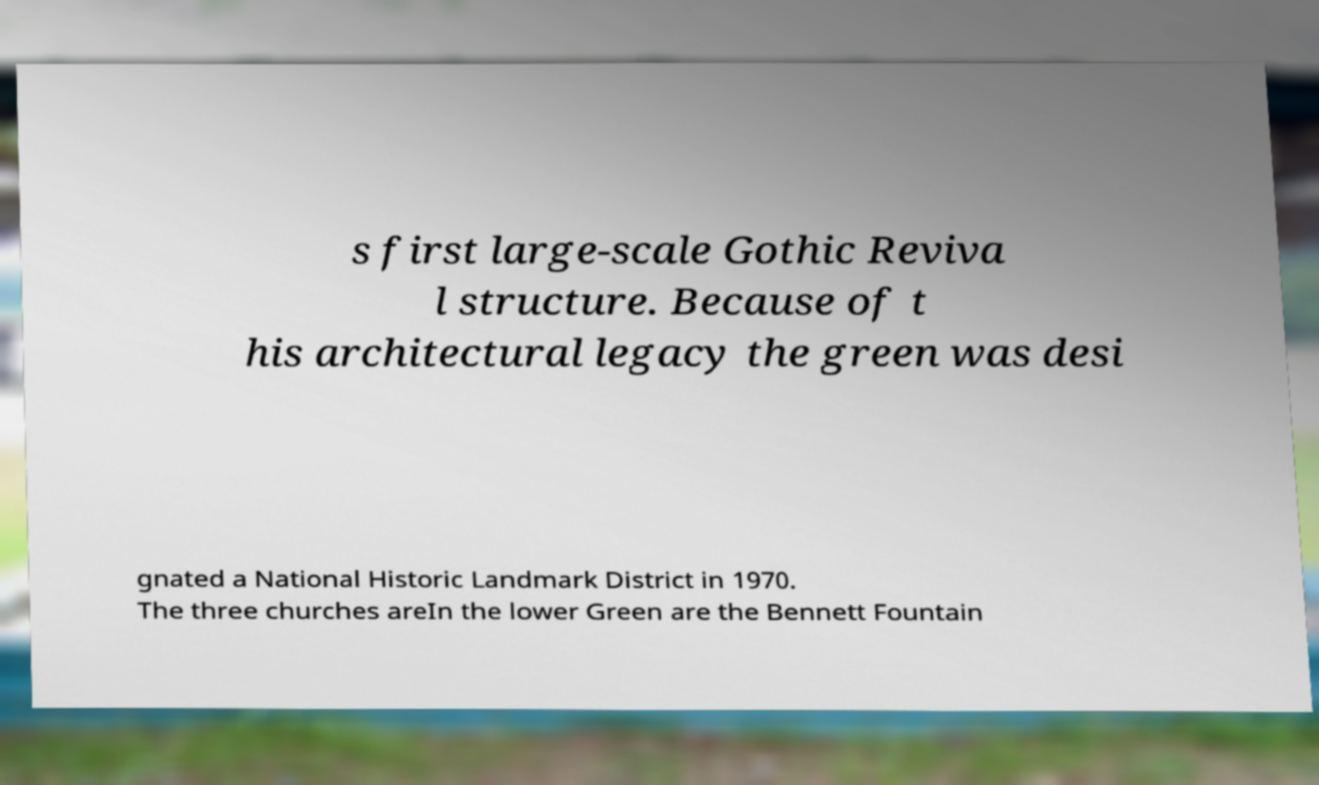Could you assist in decoding the text presented in this image and type it out clearly? s first large-scale Gothic Reviva l structure. Because of t his architectural legacy the green was desi gnated a National Historic Landmark District in 1970. The three churches areIn the lower Green are the Bennett Fountain 